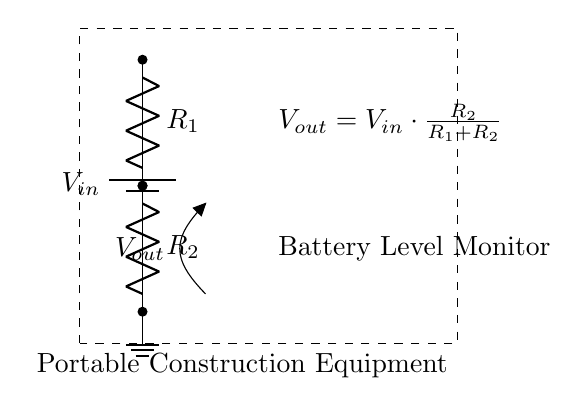What is the input voltage in this circuit? The input voltage, labeled as \(V_{in}\), is the voltage provided by the battery. Since the specific value is not given in the diagram, it remains a variable.
Answer: \(V_{in}\) What components are present in the voltage divider circuit? The components are a battery, two resistors labeled as \(R_1\) and \(R_2\), and an output voltage measurement point labeled as \(V_{out}\).
Answer: Battery, \(R_1\), \(R_2\) What is the formula for \(V_{out}\)? The formula for the output voltage, \(V_{out}\), is given as \(V_{out} = V_{in} \cdot \frac{R_2}{R_1 + R_2}\). This equation shows how the output voltage is derived from the input voltage based on the resistor values.
Answer: \(V_{out} = V_{in} \cdot \frac{R_2}{R_1 + R_2}\) How does increasing \(R_2\) affect the output voltage \(V_{out}\)? Increasing \(R_2\) will increase \(V_{out}\) because \(R_2\) is in the numerator of the voltage divider formula. As \(R_2\) goes up relative to \(R_1\), the fraction increases, leading to a higher \(V_{out}\).
Answer: Increases \(V_{out}\) What would happen to \(V_{out}\) if \(R_1\) is zero? If \(R_1\) is zero, \(V_{out}\) would equal \(V_{in}\) since the formula simplifies to \(V_{out} = V_{in} \cdot \frac{R_2}{0 + R_2}\), which results in \(V_{out} = V_{in}\). This means the entire input voltage would appear at the output.
Answer: \(V_{out} = V_{in}\) What is the purpose of this voltage divider circuit? The purpose of the voltage divider is to monitor the battery level in portable construction equipment by providing a scaled-down version of the battery voltage to a measuring device.
Answer: Battery Level Monitor 